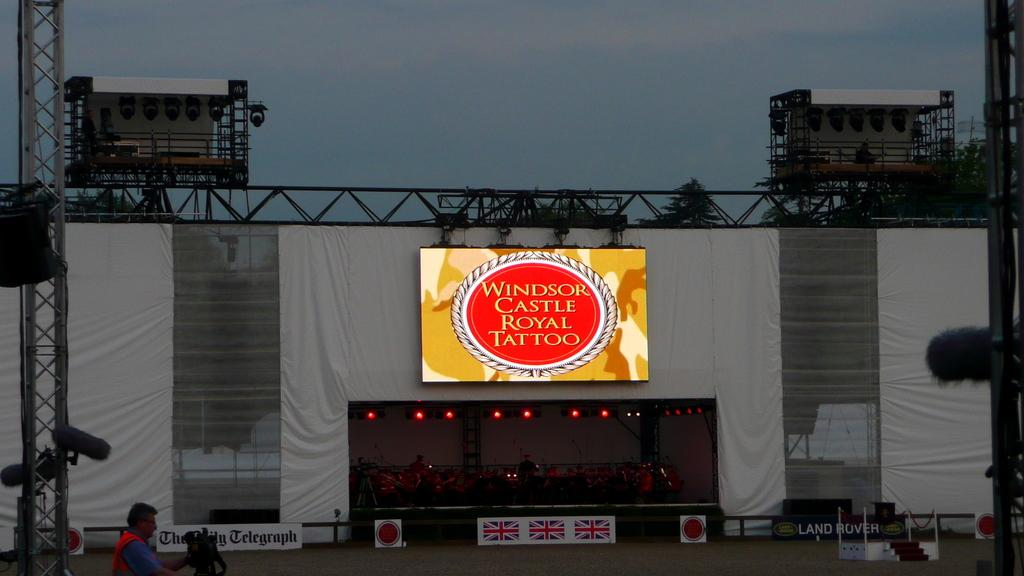<image>
Share a concise interpretation of the image provided. A sign that says windsor castle royal tattoo 